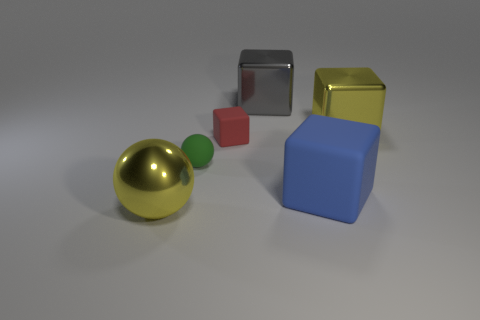There is another big metallic thing that is the same shape as the gray metal object; what color is it?
Provide a short and direct response. Yellow. Are there the same number of yellow metal spheres that are behind the big yellow shiny cube and large matte spheres?
Provide a short and direct response. Yes. How many spheres are either green matte objects or blue rubber objects?
Your response must be concise. 1. What color is the other large cube that is the same material as the yellow block?
Provide a succinct answer. Gray. Is the material of the small green ball the same as the large block that is in front of the tiny rubber block?
Offer a terse response. Yes. What number of things are red rubber cylinders or small red matte cubes?
Your answer should be compact. 1. Are there any big purple metallic objects that have the same shape as the large gray thing?
Offer a very short reply. No. There is a small matte ball; how many things are to the left of it?
Provide a short and direct response. 1. What is the material of the sphere behind the large metallic object that is to the left of the small red thing?
Your answer should be compact. Rubber. There is a cube that is the same size as the matte sphere; what is it made of?
Ensure brevity in your answer.  Rubber. 